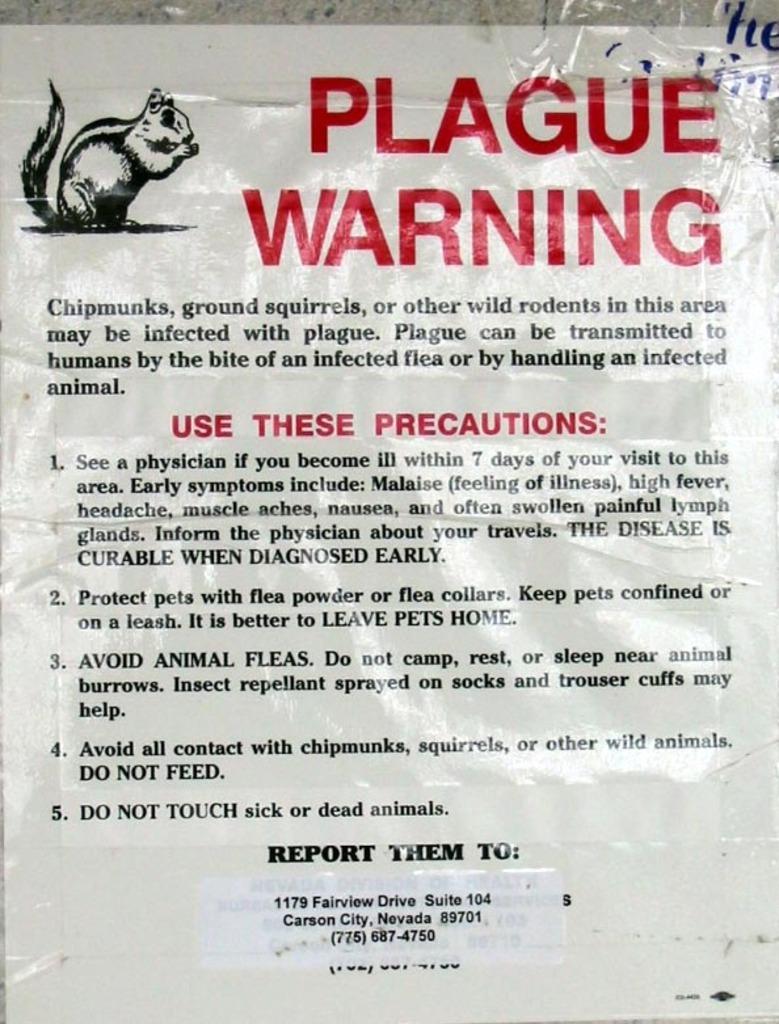Describe this image in one or two sentences. In this image there is a poster, on that poster there is some text, in the top left there is a squirrel image. 